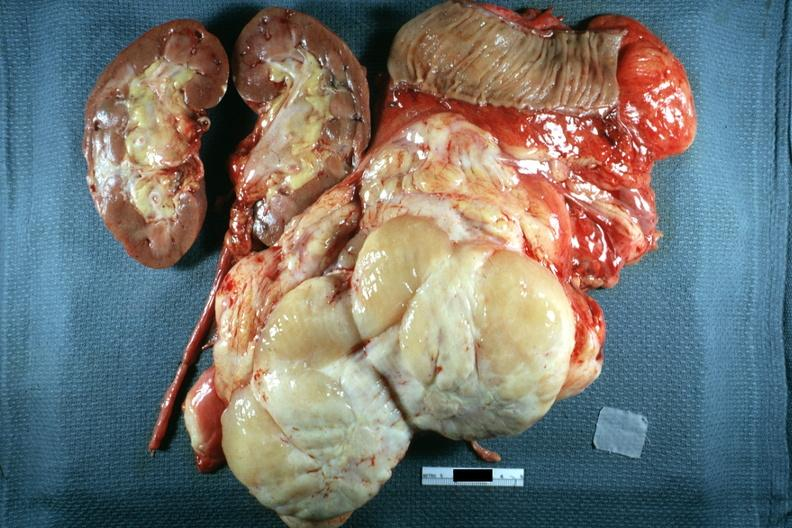s peritoneum present?
Answer the question using a single word or phrase. Yes 